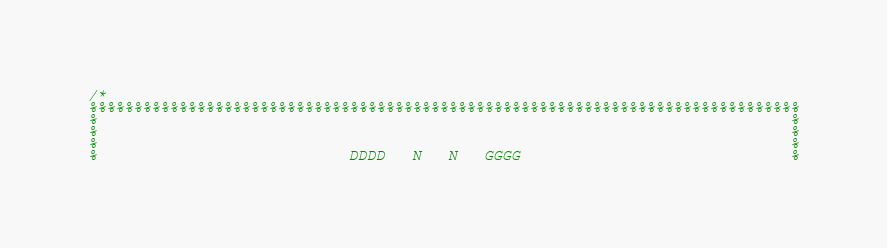<code> <loc_0><loc_0><loc_500><loc_500><_C_>/*
%%%%%%%%%%%%%%%%%%%%%%%%%%%%%%%%%%%%%%%%%%%%%%%%%%%%%%%%%%%%%%%%%%%%%%%%%%%%%%%
%                                                                             %
%                                                                             %
%                                                                             %
%                            DDDD   N   N   GGGG                              %</code> 